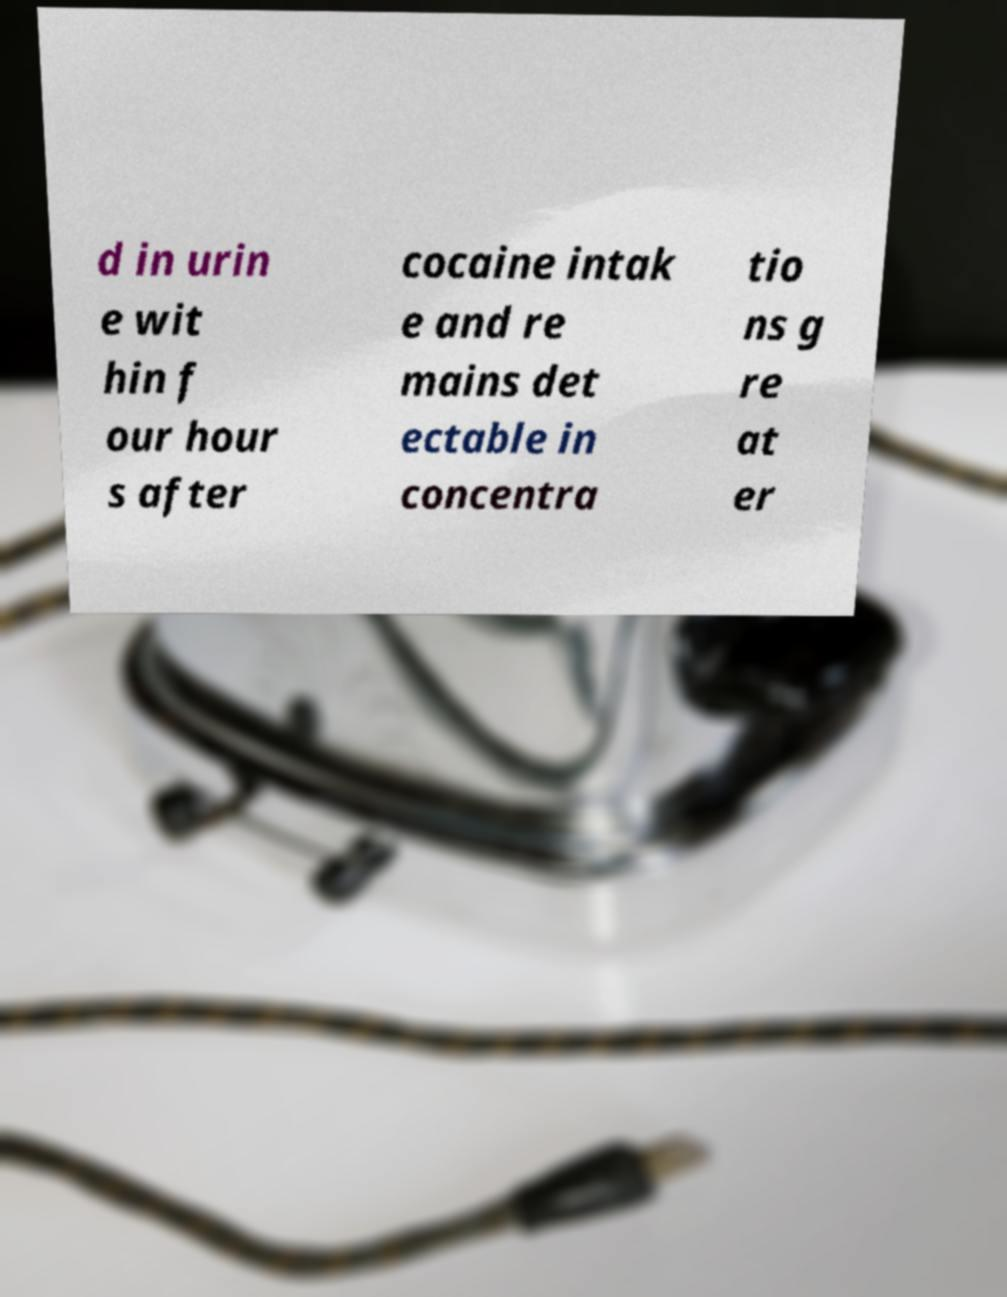I need the written content from this picture converted into text. Can you do that? d in urin e wit hin f our hour s after cocaine intak e and re mains det ectable in concentra tio ns g re at er 